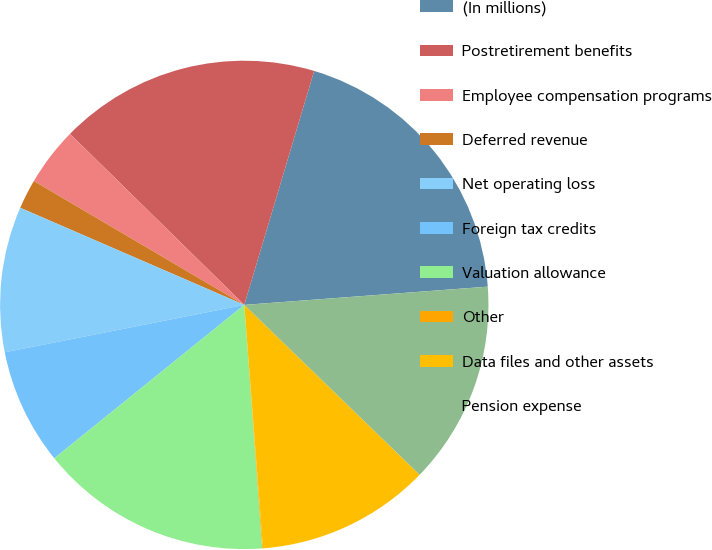<chart> <loc_0><loc_0><loc_500><loc_500><pie_chart><fcel>(In millions)<fcel>Postretirement benefits<fcel>Employee compensation programs<fcel>Deferred revenue<fcel>Net operating loss<fcel>Foreign tax credits<fcel>Valuation allowance<fcel>Other<fcel>Data files and other assets<fcel>Pension expense<nl><fcel>19.19%<fcel>17.27%<fcel>3.88%<fcel>1.96%<fcel>9.62%<fcel>7.7%<fcel>15.36%<fcel>0.05%<fcel>11.53%<fcel>13.44%<nl></chart> 